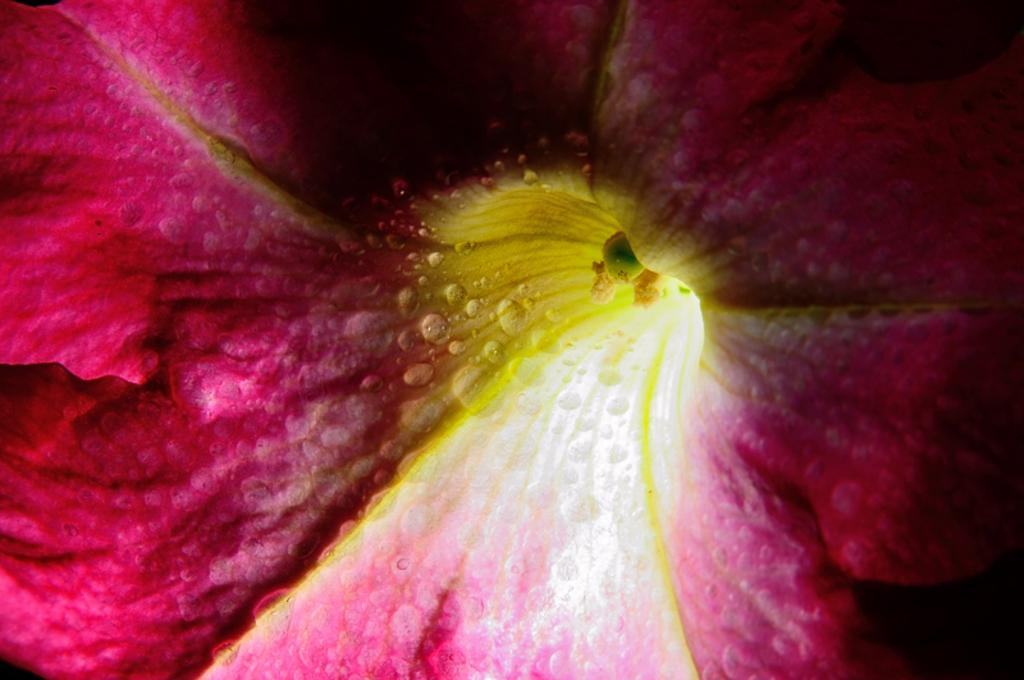What is the main subject of the image? There is a flower in the image. What color is the flower? The flower is pink in color. What is the color of the inside part of the flower? The inside part of the flower is yellow in color. What type of sheet is covering the flower in the image? There is no sheet covering the flower in the image. How is the flower being transported in the image? The flower is not being transported in the image; it is stationary. 